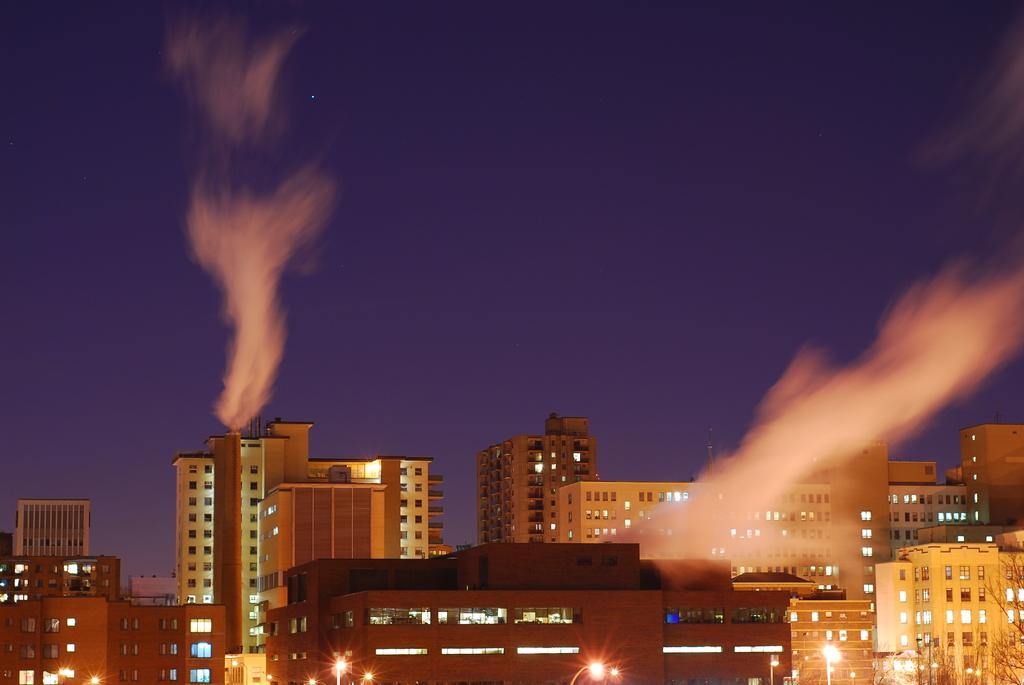What type of view is shown in the image? The image is an outside view. What structures can be seen at the bottom of the image? There are buildings at the bottom of the image. What part of the natural environment is visible in the image? The sky is visible in the background of the image. How much salt is being used to wash the buildings in the image? There is no indication in the image that the buildings are being washed or that salt is being used for any purpose. 